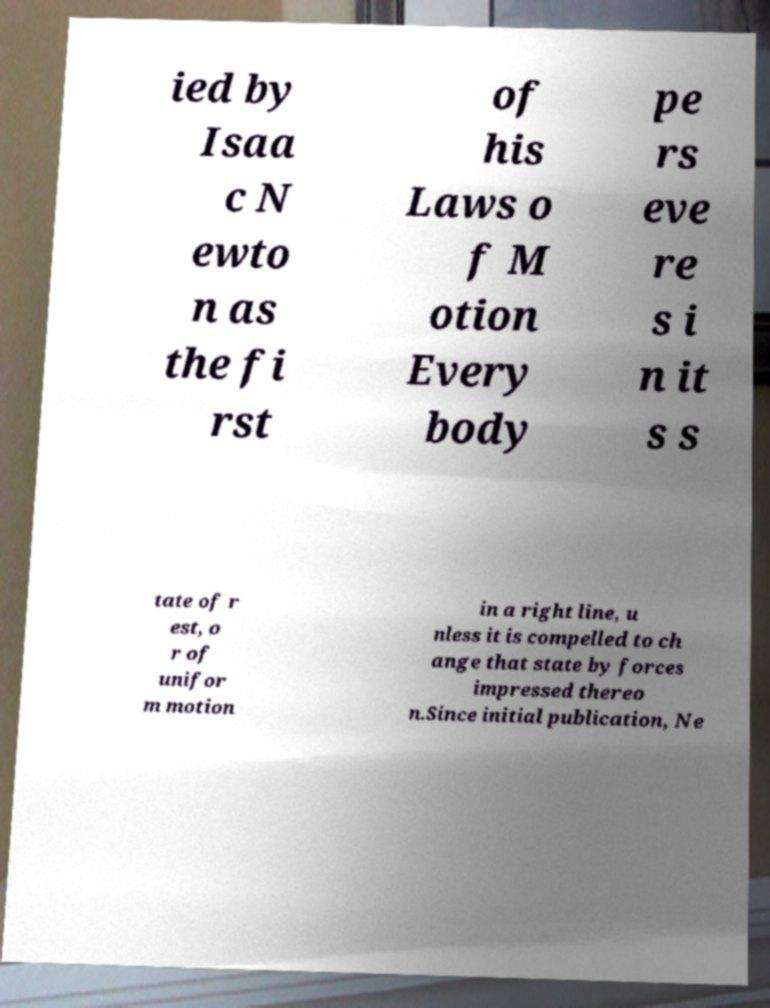Can you accurately transcribe the text from the provided image for me? ied by Isaa c N ewto n as the fi rst of his Laws o f M otion Every body pe rs eve re s i n it s s tate of r est, o r of unifor m motion in a right line, u nless it is compelled to ch ange that state by forces impressed thereo n.Since initial publication, Ne 